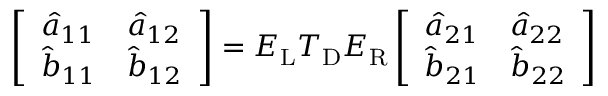Convert formula to latex. <formula><loc_0><loc_0><loc_500><loc_500>\left [ \begin{array} { l l } { \hat { a } _ { 1 1 } } & { \hat { a } _ { 1 2 } } \\ { \hat { b } _ { 1 1 } } & { \hat { b } _ { 1 2 } } \end{array} \right ] = E _ { L } T _ { D } E _ { R } \left [ \begin{array} { l l } { \hat { a } _ { 2 1 } } & { \hat { a } _ { 2 2 } } \\ { \hat { b } _ { 2 1 } } & { \hat { b } _ { 2 2 } } \end{array} \right ]</formula> 